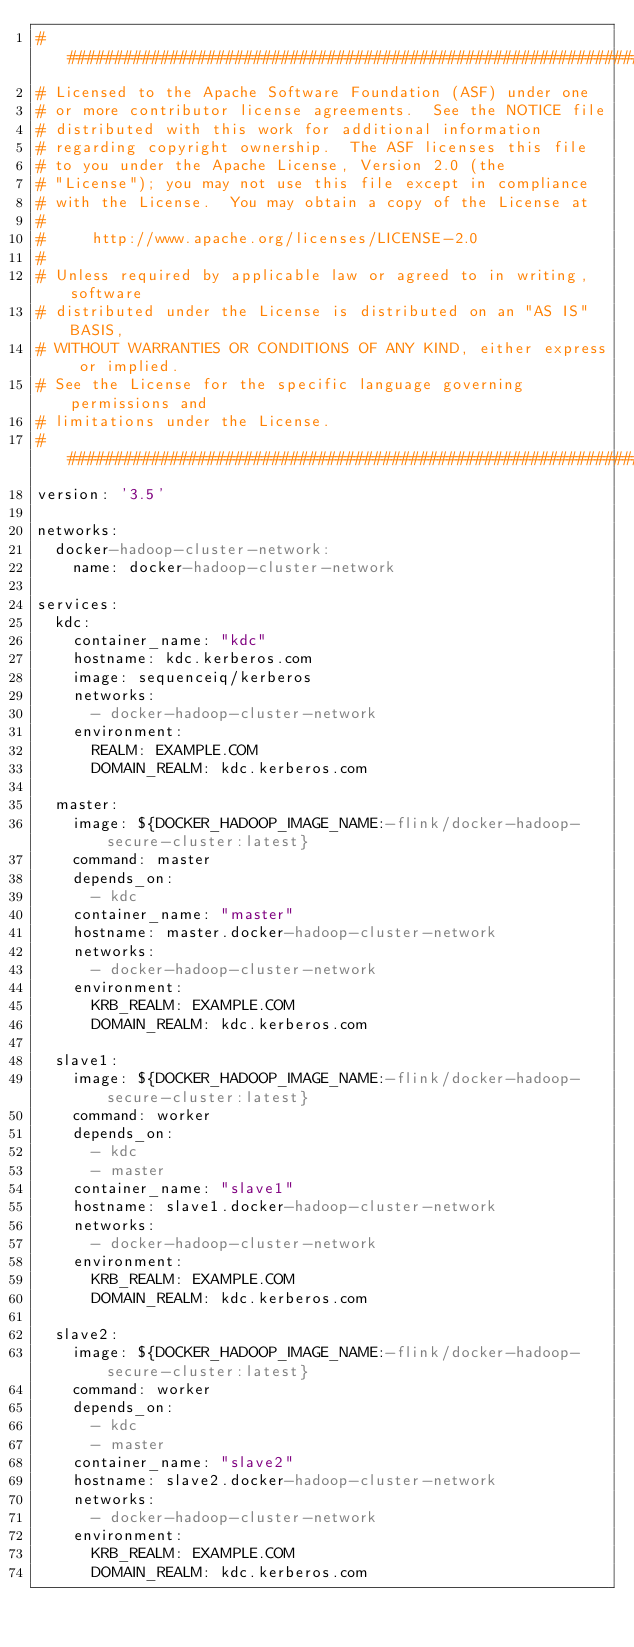Convert code to text. <code><loc_0><loc_0><loc_500><loc_500><_YAML_>################################################################################
# Licensed to the Apache Software Foundation (ASF) under one
# or more contributor license agreements.  See the NOTICE file
# distributed with this work for additional information
# regarding copyright ownership.  The ASF licenses this file
# to you under the Apache License, Version 2.0 (the
# "License"); you may not use this file except in compliance
# with the License.  You may obtain a copy of the License at
#
#     http://www.apache.org/licenses/LICENSE-2.0
#
# Unless required by applicable law or agreed to in writing, software
# distributed under the License is distributed on an "AS IS" BASIS,
# WITHOUT WARRANTIES OR CONDITIONS OF ANY KIND, either express or implied.
# See the License for the specific language governing permissions and
# limitations under the License.
################################################################################
version: '3.5'

networks:
  docker-hadoop-cluster-network:
    name: docker-hadoop-cluster-network

services:
  kdc:
    container_name: "kdc"
    hostname: kdc.kerberos.com
    image: sequenceiq/kerberos
    networks:
      - docker-hadoop-cluster-network
    environment:
      REALM: EXAMPLE.COM
      DOMAIN_REALM: kdc.kerberos.com

  master:
    image: ${DOCKER_HADOOP_IMAGE_NAME:-flink/docker-hadoop-secure-cluster:latest}
    command: master
    depends_on:
      - kdc
    container_name: "master"
    hostname: master.docker-hadoop-cluster-network
    networks:
      - docker-hadoop-cluster-network
    environment:
      KRB_REALM: EXAMPLE.COM
      DOMAIN_REALM: kdc.kerberos.com

  slave1:
    image: ${DOCKER_HADOOP_IMAGE_NAME:-flink/docker-hadoop-secure-cluster:latest}
    command: worker
    depends_on:
      - kdc
      - master
    container_name: "slave1"
    hostname: slave1.docker-hadoop-cluster-network
    networks:
      - docker-hadoop-cluster-network
    environment:
      KRB_REALM: EXAMPLE.COM
      DOMAIN_REALM: kdc.kerberos.com

  slave2:
    image: ${DOCKER_HADOOP_IMAGE_NAME:-flink/docker-hadoop-secure-cluster:latest}
    command: worker
    depends_on:
      - kdc
      - master
    container_name: "slave2"
    hostname: slave2.docker-hadoop-cluster-network
    networks:
      - docker-hadoop-cluster-network
    environment:
      KRB_REALM: EXAMPLE.COM
      DOMAIN_REALM: kdc.kerberos.com
</code> 